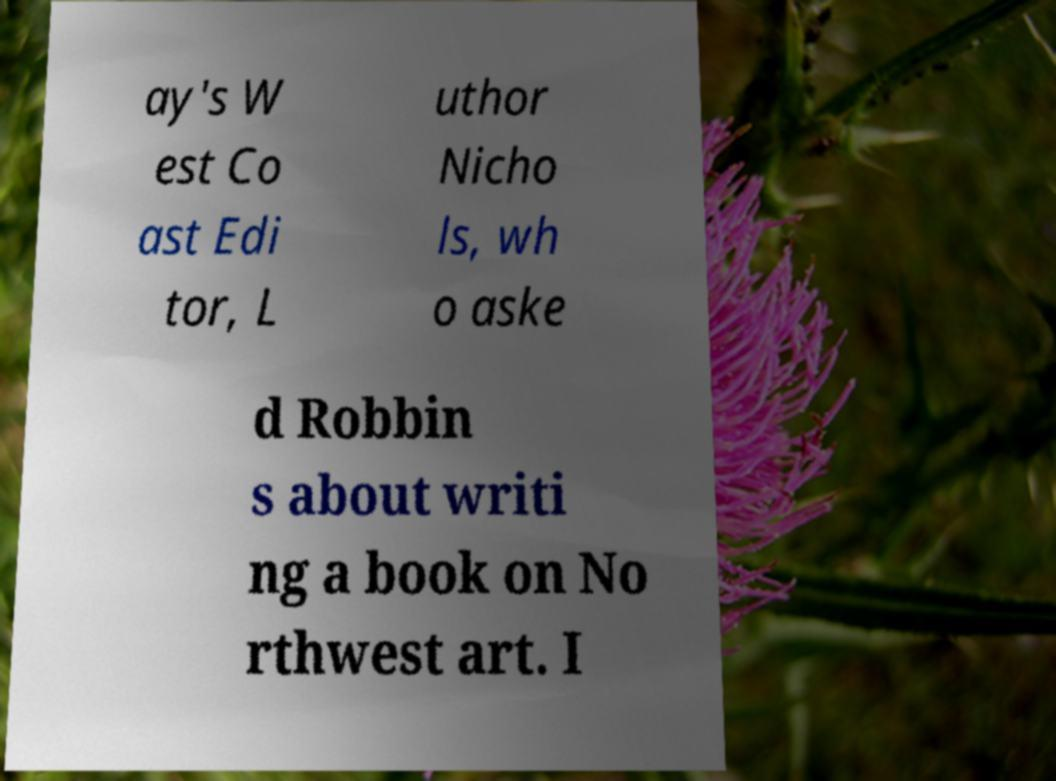Please read and relay the text visible in this image. What does it say? ay's W est Co ast Edi tor, L uthor Nicho ls, wh o aske d Robbin s about writi ng a book on No rthwest art. I 